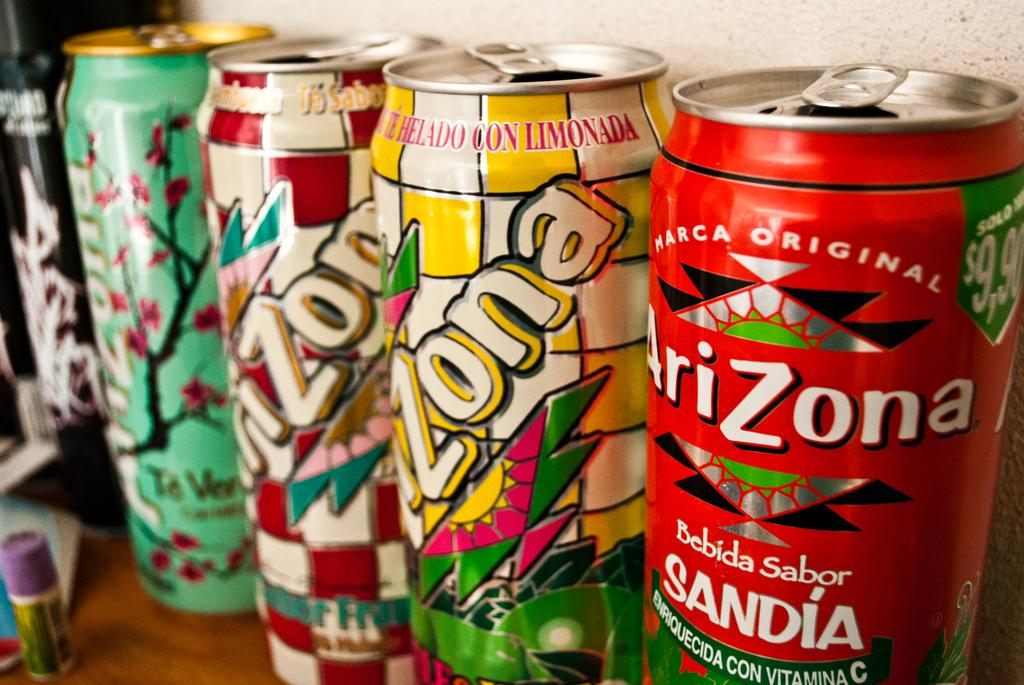Provide a one-sentence caption for the provided image. A collection of opened Arizona cans sit on a desk. 